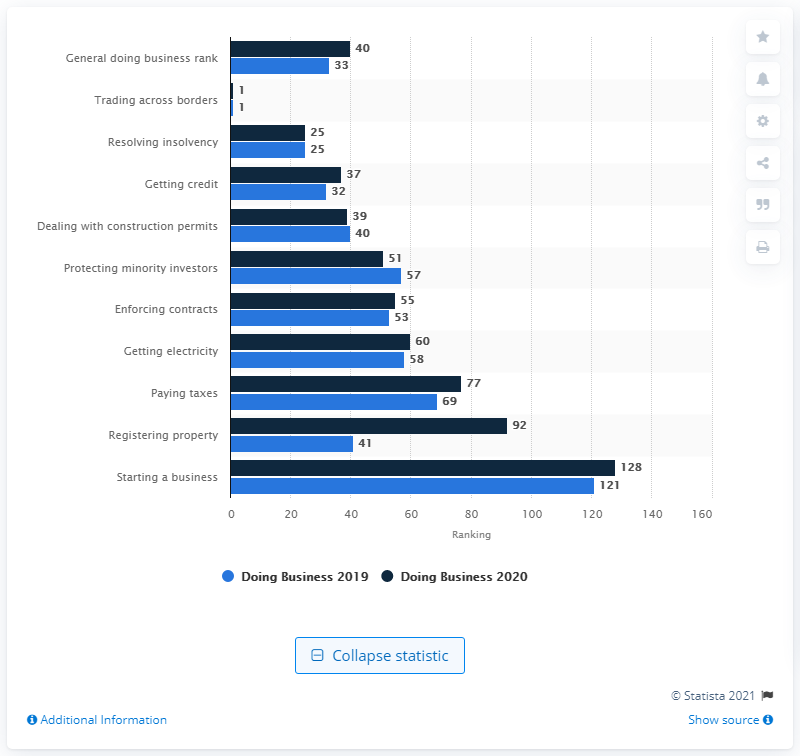List a handful of essential elements in this visual. According to the Doing Business report for 2023, Poland's general ease of doing business ranking was 40 out of 190 countries. 